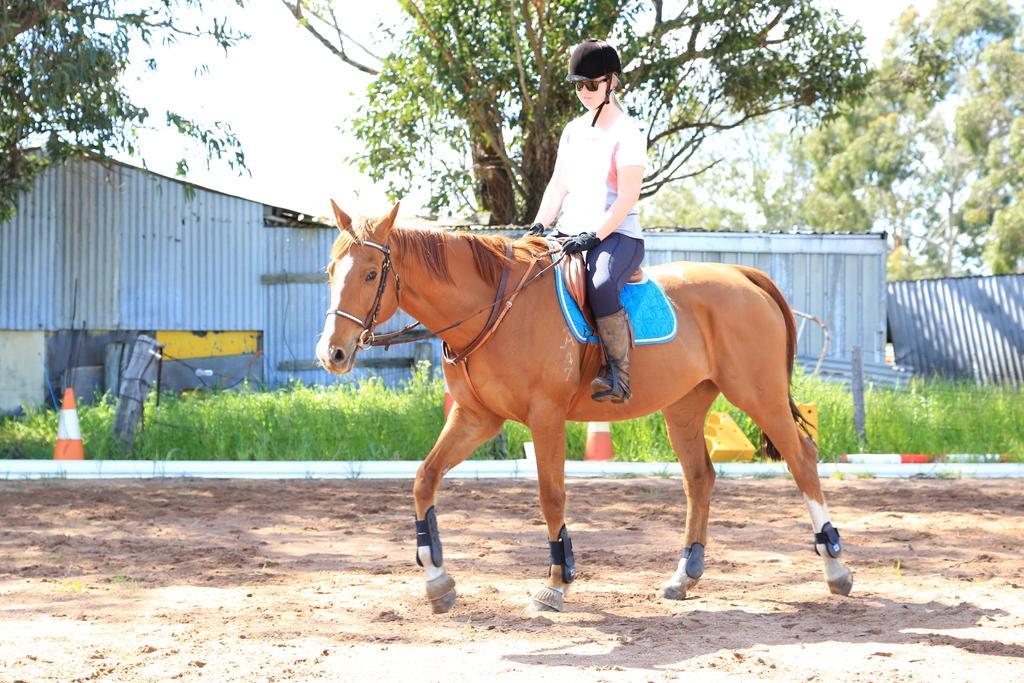Please provide a concise description of this image. In this picture I can see the horse in front and I see a girl sitting on it and in the middle of this picture I can see the grass and 2 traffic cones. In the background I can see the trees and the sky. 